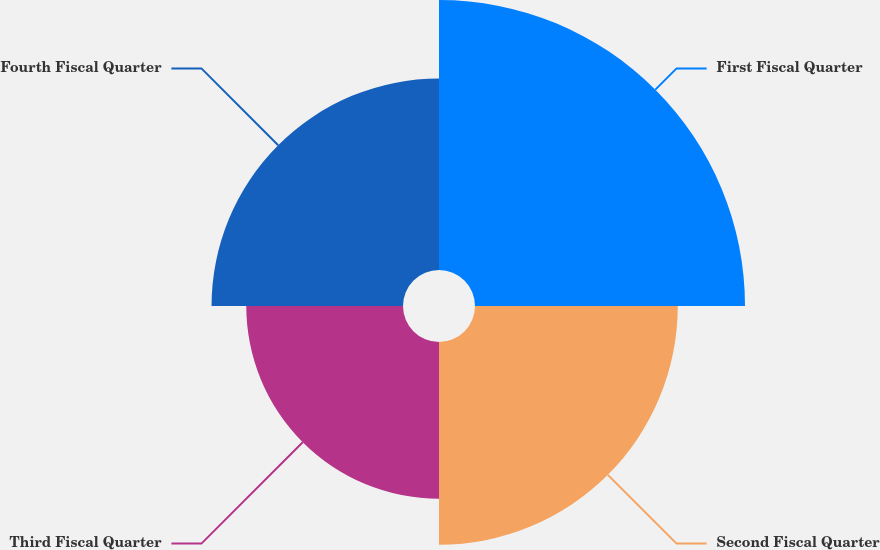<chart> <loc_0><loc_0><loc_500><loc_500><pie_chart><fcel>First Fiscal Quarter<fcel>Second Fiscal Quarter<fcel>Third Fiscal Quarter<fcel>Fourth Fiscal Quarter<nl><fcel>32.89%<fcel>24.7%<fcel>19.09%<fcel>23.32%<nl></chart> 